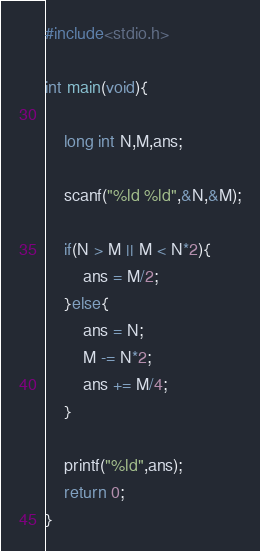<code> <loc_0><loc_0><loc_500><loc_500><_C_>#include<stdio.h>

int main(void){

    long int N,M,ans;

    scanf("%ld %ld",&N,&M);

    if(N > M || M < N*2){
        ans = M/2;
    }else{
        ans = N;
        M -= N*2;
        ans += M/4;
    }

    printf("%ld",ans);
    return 0;
}
</code> 